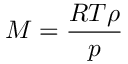<formula> <loc_0><loc_0><loc_500><loc_500>M = \frac { R T \rho } { p }</formula> 